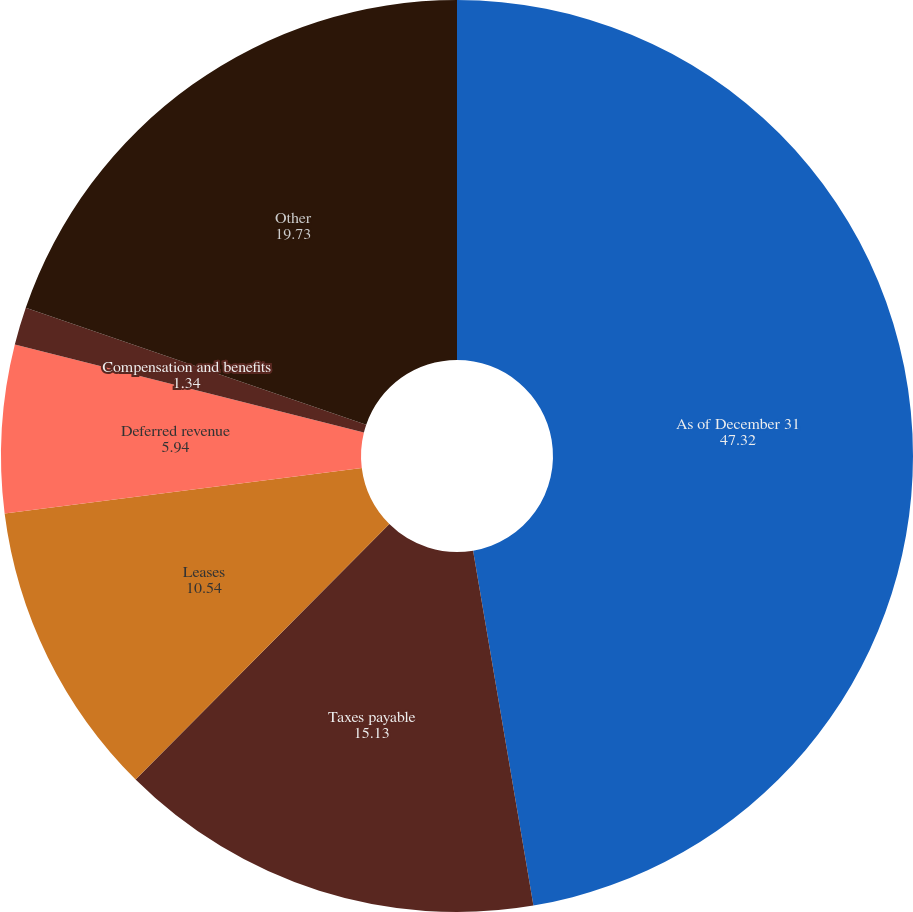Convert chart to OTSL. <chart><loc_0><loc_0><loc_500><loc_500><pie_chart><fcel>As of December 31<fcel>Taxes payable<fcel>Leases<fcel>Deferred revenue<fcel>Compensation and benefits<fcel>Other<nl><fcel>47.32%<fcel>15.13%<fcel>10.54%<fcel>5.94%<fcel>1.34%<fcel>19.73%<nl></chart> 